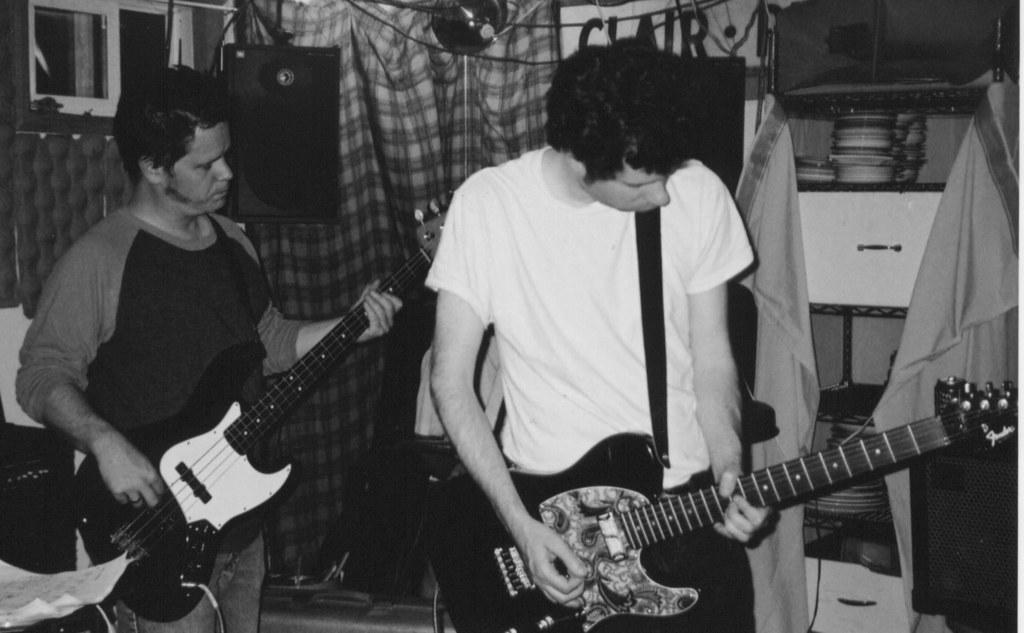Can you describe this image briefly? The picture is taken in a closed room in that two people are playing a guitar on the left corner of the picture one person is wearing a t-shirt and jeans and at the right corner of the picture another person is wearing a white t-shirt, behind them there is a curtain and speakers and small window and at the right corner of the picture there are plates on the shelfs and some clothes on them. 